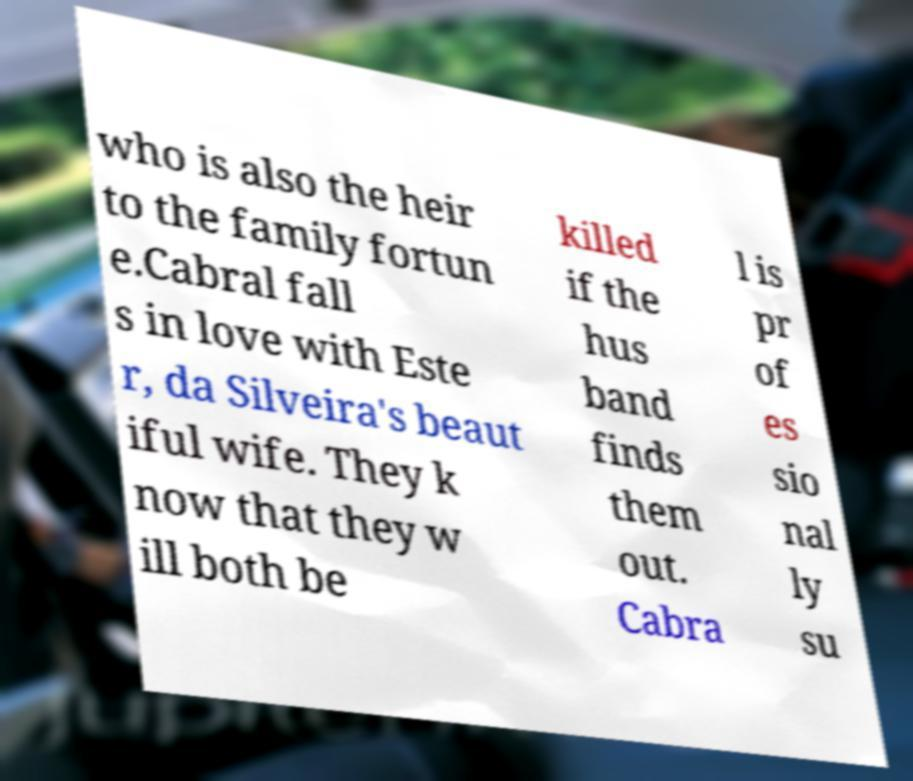Could you extract and type out the text from this image? who is also the heir to the family fortun e.Cabral fall s in love with Este r, da Silveira's beaut iful wife. They k now that they w ill both be killed if the hus band finds them out. Cabra l is pr of es sio nal ly su 